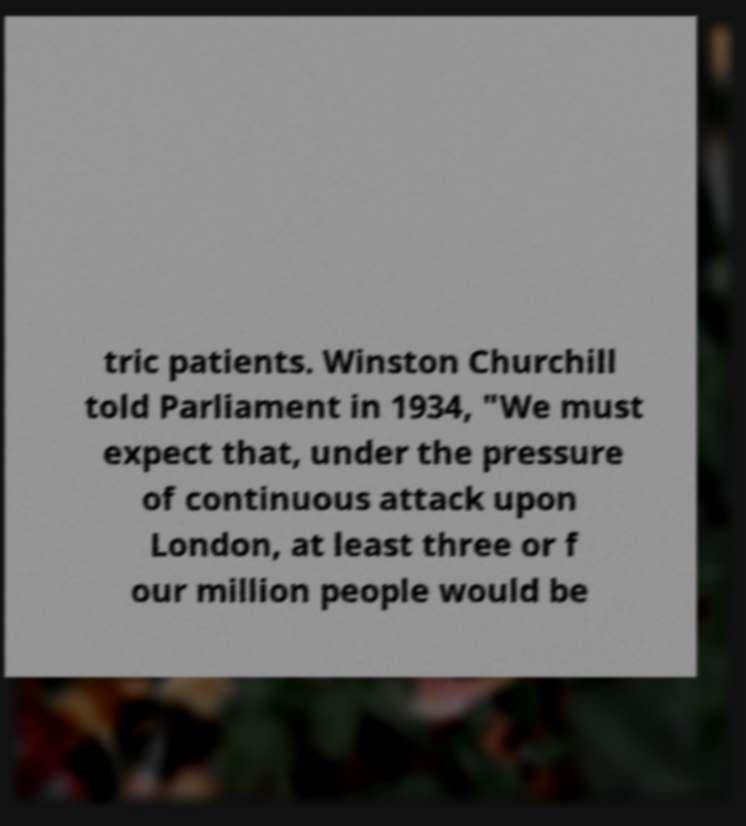Please identify and transcribe the text found in this image. tric patients. Winston Churchill told Parliament in 1934, "We must expect that, under the pressure of continuous attack upon London, at least three or f our million people would be 